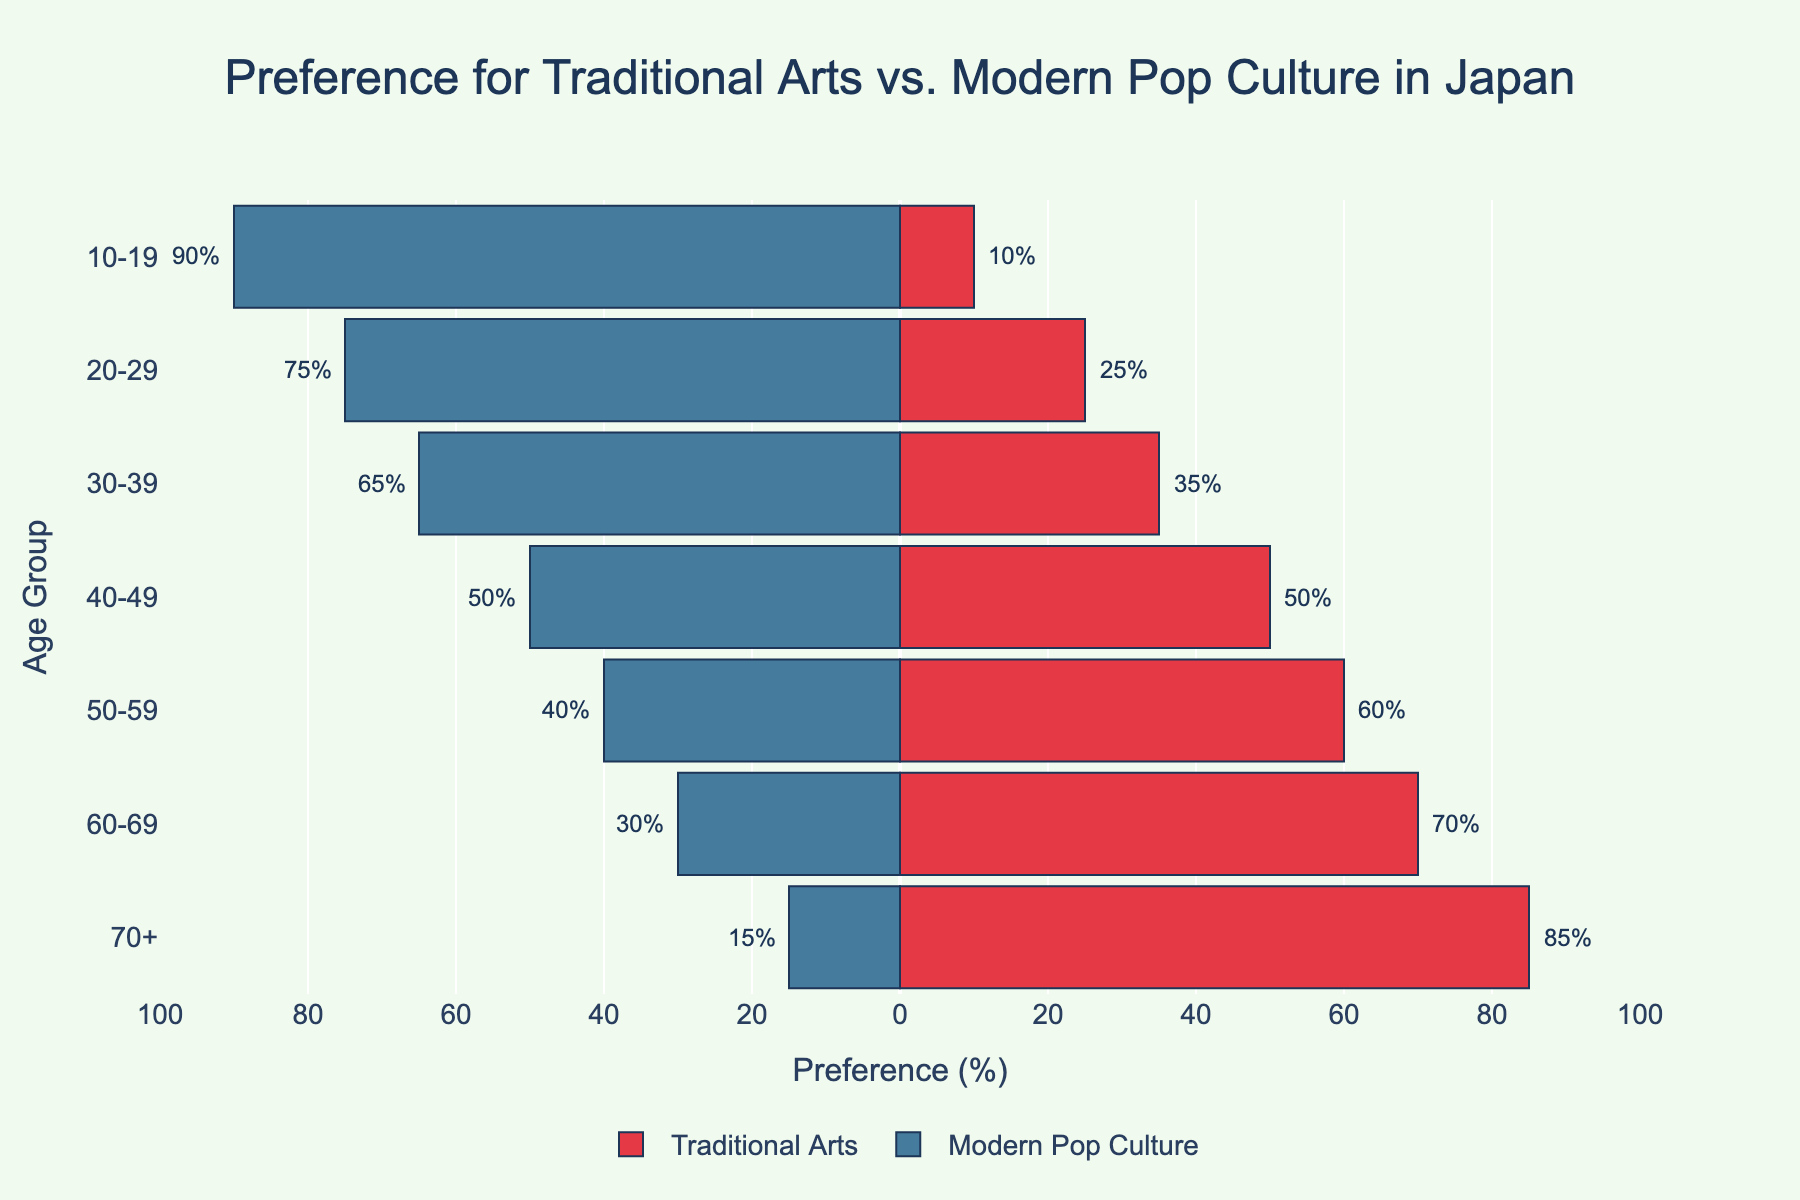What's the age group with the highest preference for Traditional Arts? The visualization shows the values of preferences for Traditional Arts and Modern Pop Culture across different age groups. The bar representing the age group with the highest preference for Traditional Arts extends furthest to the right. The 70+ age group has the highest value at 85%.
Answer: 70+ Which age group has an equal preference for Traditional Arts and Modern Pop Culture? Look for the age group where the bars for Traditional Arts and Modern Pop Culture are of equal length. The figure shows that the 40-49 age group has equal preferences, with both bars extending to 50%.
Answer: 40-49 Compare the preference for Modern Pop Culture between the 10-19 and 60-69 age groups. Which age group prefers it more? Check the bar lengths for Modern Pop Culture in the 10-19 and 60-69 age groups. The 10-19 age group has a Modern Pop Culture preference bar at -90%, while the 60-69 age group has a bar at -30%. Hence, the 10-19 age group prefers Modern Pop Culture more.
Answer: 10-19 What’s the total preference percentage for Traditional Arts among the age groups 50-59 and 60-69? Add the values of preference percentages for Traditional Arts from 50-59 and 60-69 age groups: 60% + 70% = 130%.
Answer: 130% How does the preference for Traditional Arts change as age increases from 10-19 to 70+? Observe the trend in the bar lengths for Traditional Arts across the age groups from 10-19 up to 70+. The preference for Traditional Arts increases progressively from 10% to 85%.
Answer: It increases Which age group has the least interest in Traditional Arts, and what is their preference percentage? The bar that extends the shortest to the right corresponds to the age group with the least interest in Traditional Arts. The 20-29 age group shows the lowest preference at 25%.
Answer: 20-29 Compare the combined preference percentages for Traditional Arts and Modern Pop Culture in the 30-39 age group. Which is higher, and by how much? Sum up the absolute values of preferences for both Traditional Arts and Modern Pop Culture for the 30-39 age group. Traditional Arts: 35%, Modern Pop Culture: 65%. Modern Pop Culture is higher by 65% - 35% = 30%.
Answer: Modern Pop Culture by 30% Which color represents the Modern Pop Culture preferences? Look at the bars representing Modern Pop Culture preferences. The color of these bars is blue.
Answer: Blue What’s the average preference percentage for Traditional Arts in the given age groups? Calculate the average by summing up the preferences for Traditional Arts and dividing by the number of age groups. Total = 10% + 25% + 35% + 50% + 60% + 70% + 85% = 335%. Average = 335% / 7 ≈ 47.86%.
Answer: 47.86% 